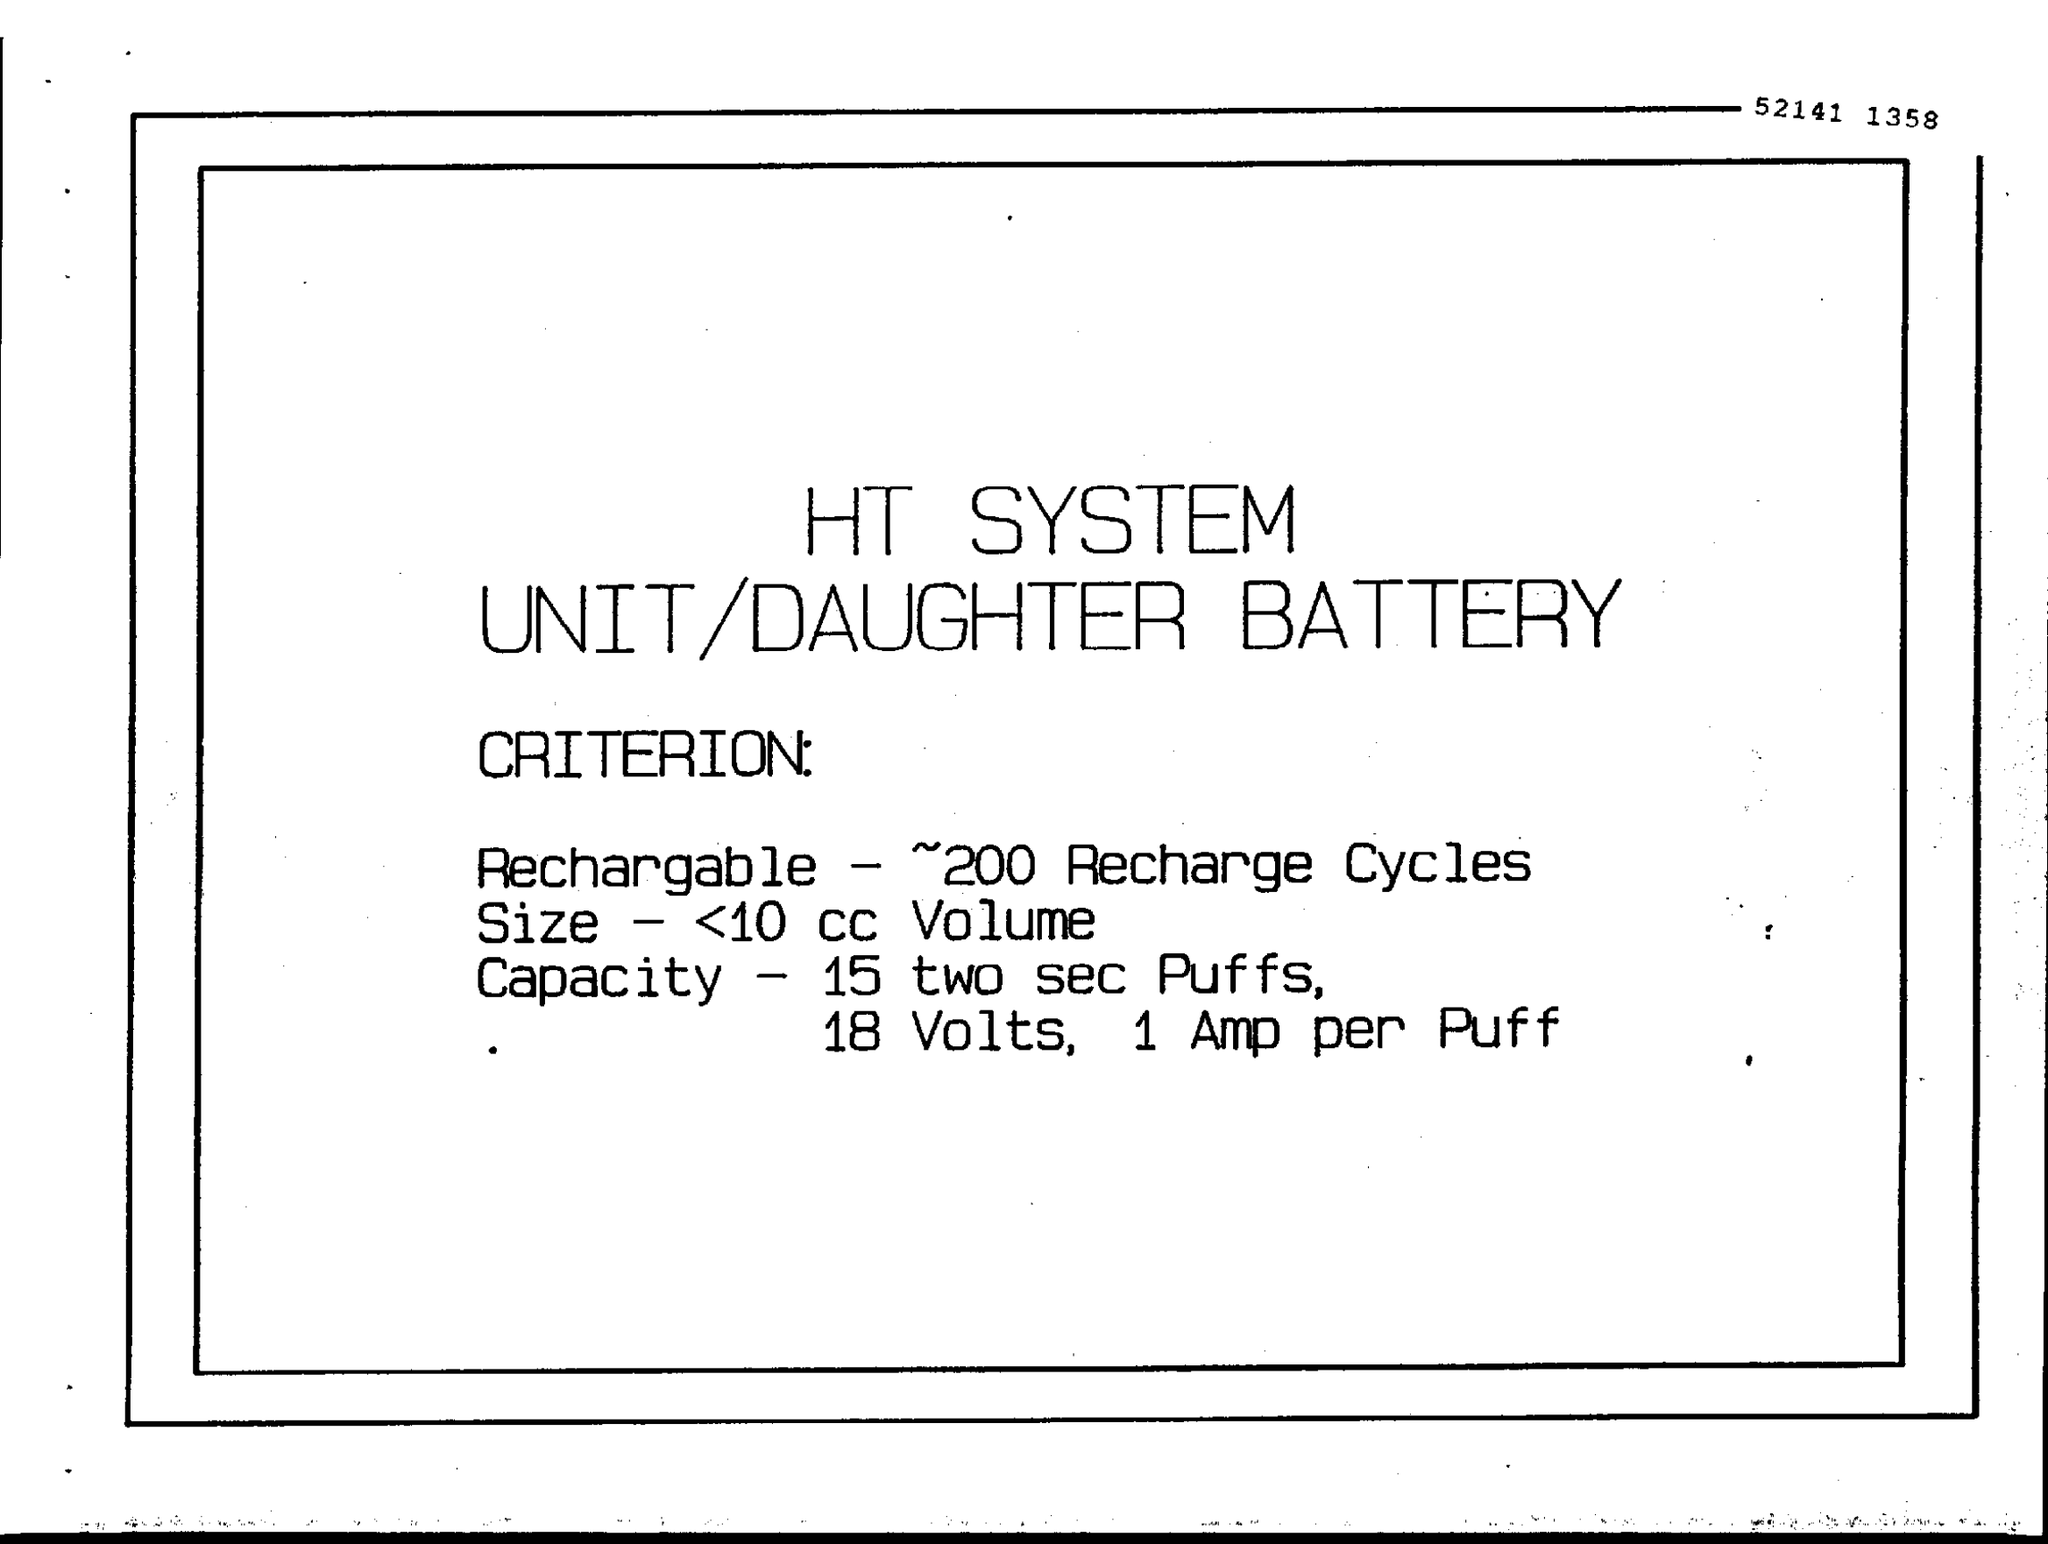What is the size of the battery?
Keep it short and to the point. < 10 cc Volume. What is the capacity of the battery?
Offer a very short reply. 15 two sec Puffs, 18 Volts, 1 Amp per Puff. 